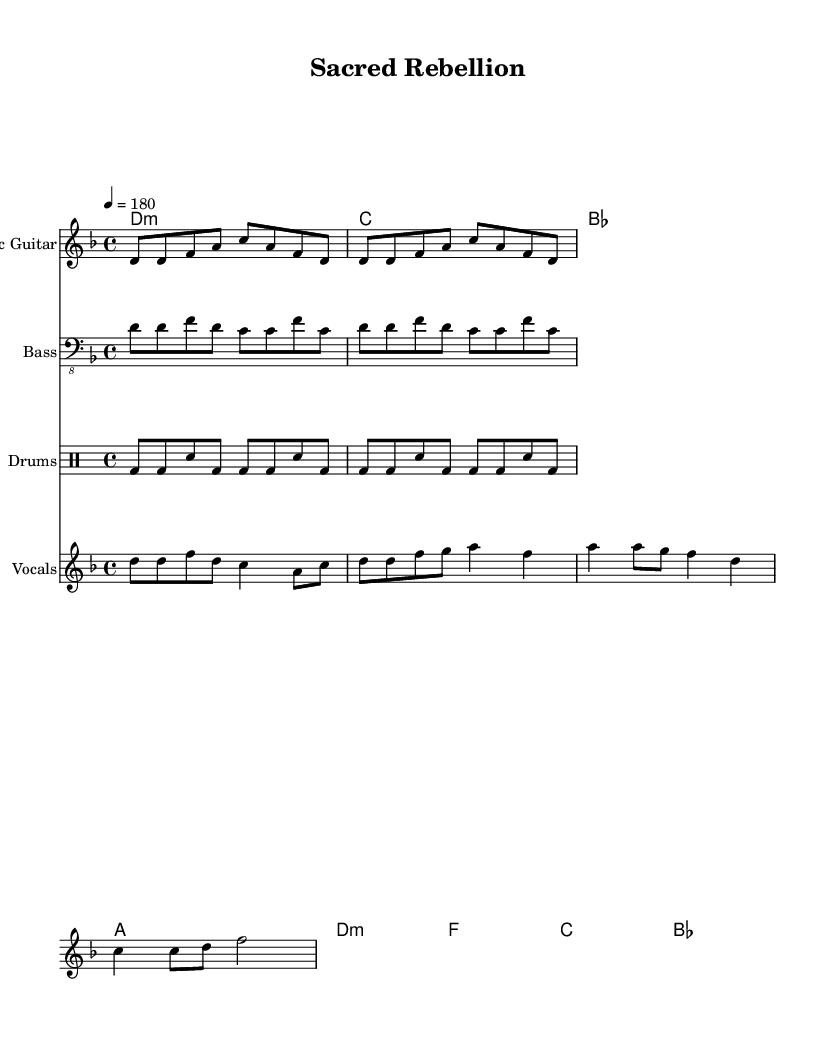What is the key signature of this music? The key signature is D minor, as indicated by the presence of one flat (B flat) and the corresponding minor tonality.
Answer: D minor What is the time signature of this music? The time signature is 4/4, which is indicated clear from the top of the music staff, allowing for four beats in each measure.
Answer: 4/4 What is the tempo marking of this music? The tempo marking states "4 = 180", indicating a brisk speed of 180 beats per minute for the quarter note.
Answer: 180 How many measures are in the verse section? The verse section consists of 4 measures, which can be counted based on the lyric and musical phrases provided.
Answer: 4 What is the primary theme of the lyrics? The primary theme of the lyrics is faith opposing adversity, as expressed in the words "In the name of faith, we rise against the tide."
Answer: Faith and rebellion What chord follows the D minor in the verse section? The chord that follows D minor is C major, indicated in the chord progression listed.
Answer: C major What is the main genre influence evident in the music? The music exemplifies punk influences through its fast tempo, simple chord structures, and anti-establishment themes woven into the lyrics.
Answer: Punk 